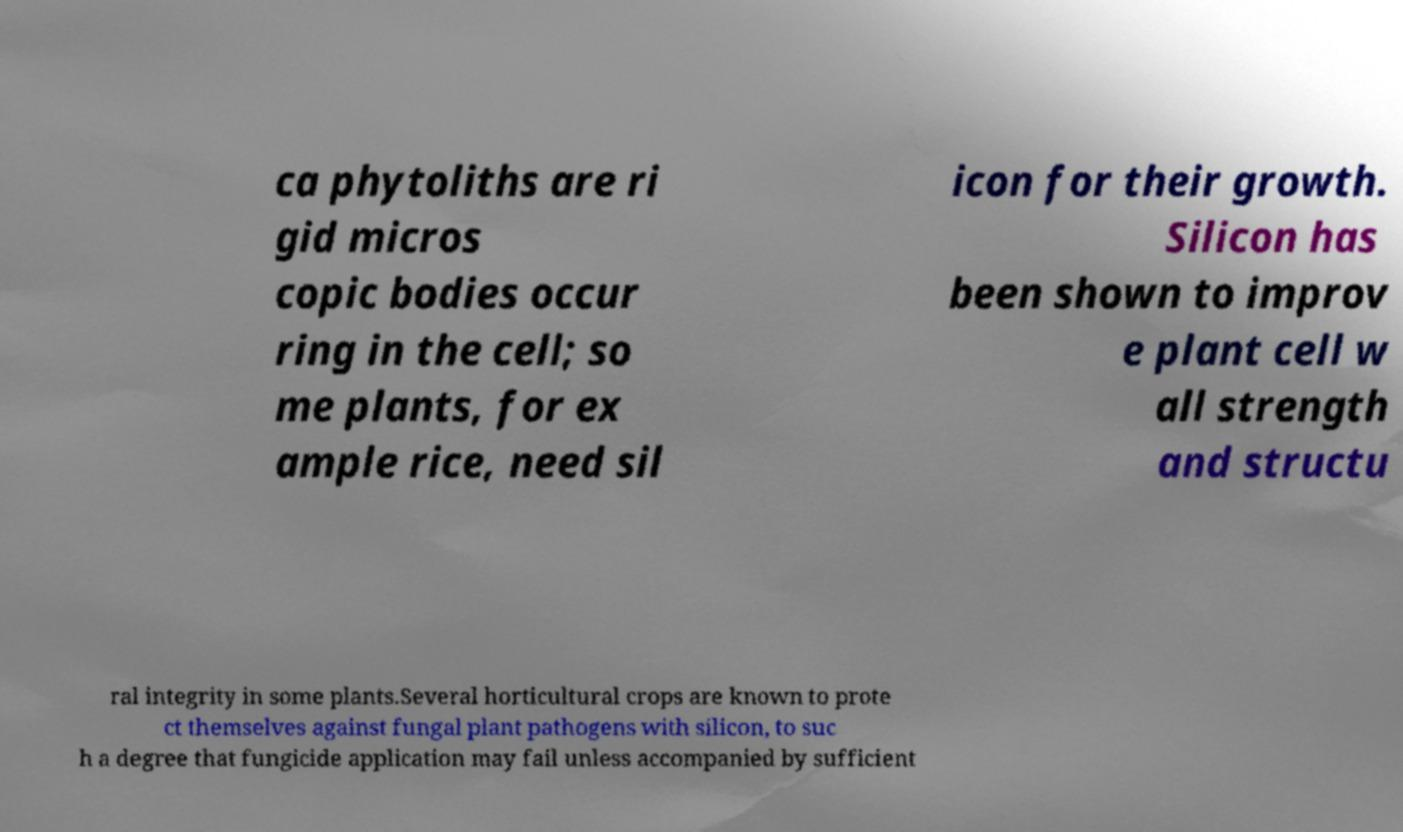Can you read and provide the text displayed in the image?This photo seems to have some interesting text. Can you extract and type it out for me? ca phytoliths are ri gid micros copic bodies occur ring in the cell; so me plants, for ex ample rice, need sil icon for their growth. Silicon has been shown to improv e plant cell w all strength and structu ral integrity in some plants.Several horticultural crops are known to prote ct themselves against fungal plant pathogens with silicon, to suc h a degree that fungicide application may fail unless accompanied by sufficient 